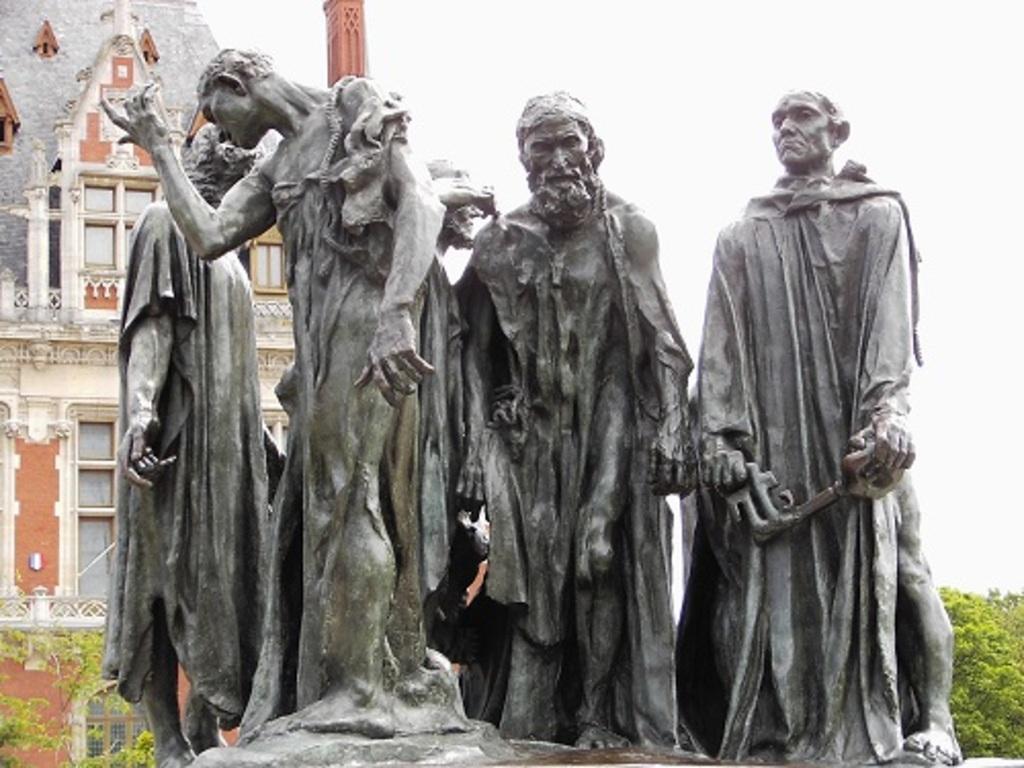Describe this image in one or two sentences. In this image we can see the statue of few people. There is a building and it is having few windows. There are few trees in the image. We can see the sky in the image. 